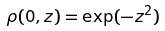Convert formula to latex. <formula><loc_0><loc_0><loc_500><loc_500>\rho ( 0 , z ) = \exp ( - z ^ { 2 } )</formula> 